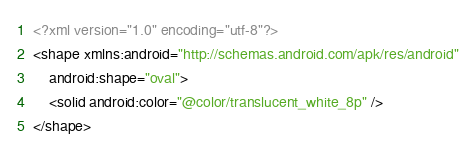<code> <loc_0><loc_0><loc_500><loc_500><_XML_><?xml version="1.0" encoding="utf-8"?>
<shape xmlns:android="http://schemas.android.com/apk/res/android"
    android:shape="oval">
    <solid android:color="@color/translucent_white_8p" />
</shape></code> 